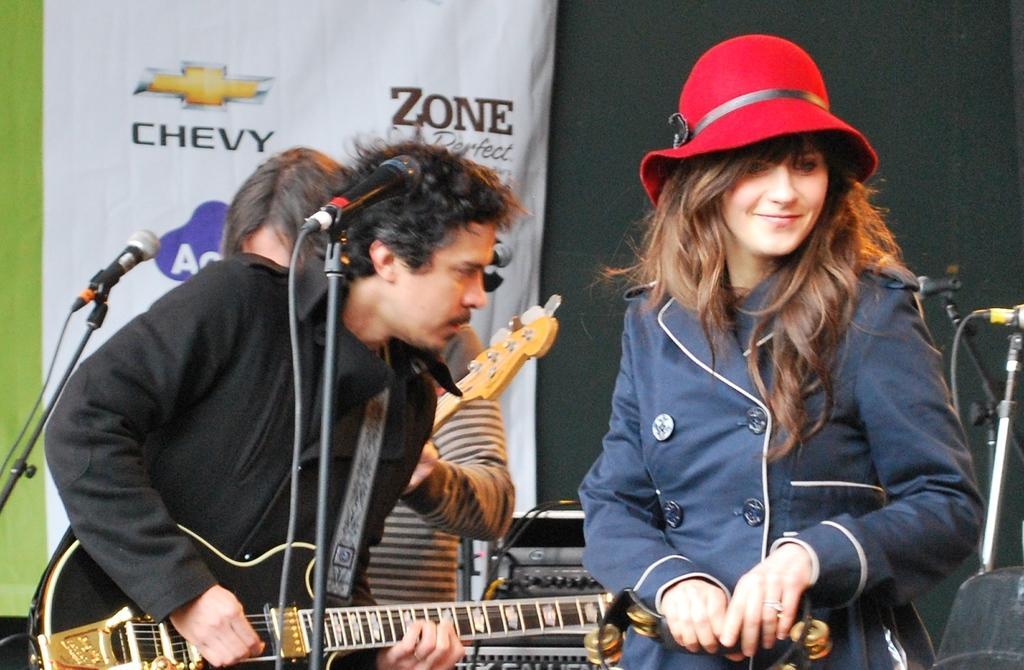Please provide a concise description of this image. In this picture there are three people on the stage, the lady who is standing at the right side of the image is playing the music instrument and the boy who is standing at the left side of the image is playing the guitar and there is a mic in front of him the other boy who is standing at the left side of the image is also playing the guitar. 